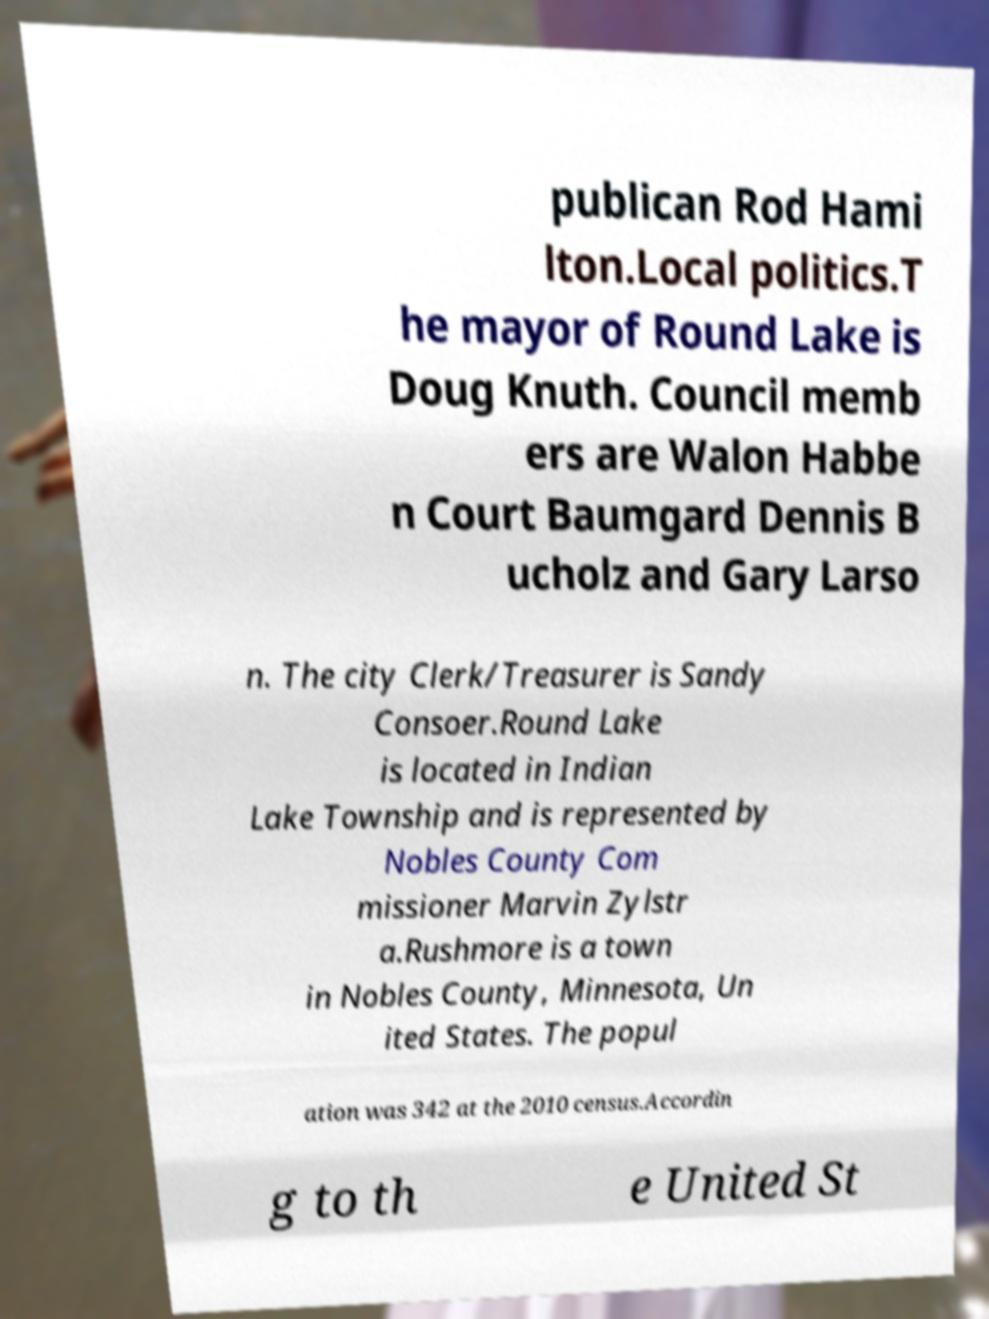There's text embedded in this image that I need extracted. Can you transcribe it verbatim? publican Rod Hami lton.Local politics.T he mayor of Round Lake is Doug Knuth. Council memb ers are Walon Habbe n Court Baumgard Dennis B ucholz and Gary Larso n. The city Clerk/Treasurer is Sandy Consoer.Round Lake is located in Indian Lake Township and is represented by Nobles County Com missioner Marvin Zylstr a.Rushmore is a town in Nobles County, Minnesota, Un ited States. The popul ation was 342 at the 2010 census.Accordin g to th e United St 